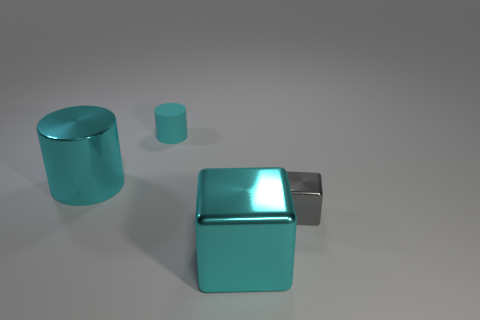What number of green metal objects are there?
Your answer should be compact. 0. Is there any other thing that has the same size as the gray metal thing?
Give a very brief answer. Yes. Are the cyan cube and the gray thing made of the same material?
Offer a terse response. Yes. There is a shiny object that is in front of the gray object; does it have the same size as the metal object that is left of the cyan rubber object?
Keep it short and to the point. Yes. Are there fewer gray rubber balls than big cyan blocks?
Your answer should be compact. Yes. How many rubber objects are tiny blocks or small cyan cylinders?
Provide a succinct answer. 1. Are there any tiny things that are on the left side of the cyan shiny thing that is on the right side of the big cyan cylinder?
Your response must be concise. Yes. Are the tiny thing in front of the small cyan cylinder and the small cyan thing made of the same material?
Offer a very short reply. No. What number of other things are there of the same color as the tiny metal thing?
Give a very brief answer. 0. Does the large cylinder have the same color as the matte cylinder?
Provide a short and direct response. Yes. 